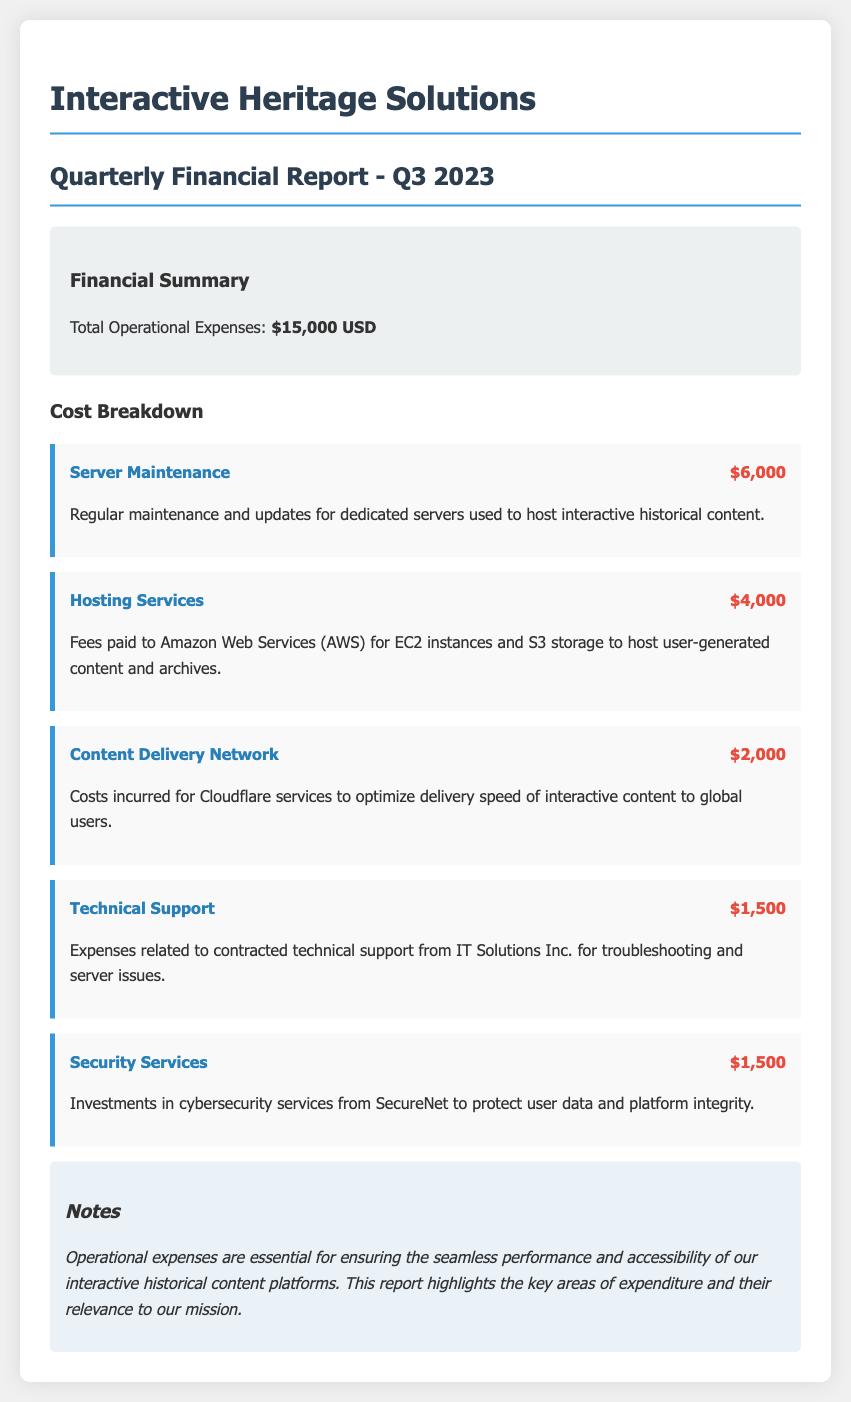What is the total operational expenses? The total operational expenses is stated in the summary section of the document as $15,000 USD.
Answer: $15,000 USD How much was spent on server maintenance? The server maintenance cost is detailed in the cost breakdown section, and it indicates an expenditure of $6,000.
Answer: $6,000 What service incurred a cost of $4,000? The hosting services cost is specified in the breakdown as $4,000, referring to fees paid to Amazon Web Services.
Answer: Hosting Services What was the cost for the content delivery network? The cost breakdown lists the content delivery network expense as $2,000.
Answer: $2,000 What is the combined total for technical support and security services? The total for both technical support ($1,500) and security services ($1,500) is calculated to be $3,000.
Answer: $3,000 What company provides the technical support listed in the report? The technical support is provided by IT Solutions Inc., as mentioned in the document.
Answer: IT Solutions Inc What is the purpose of the operational expenses according to the notes? The notes section states that operational expenses are essential for ensuring seamless performance and accessibility of the platforms.
Answer: Ensuring seamless performance and accessibility How much was spent on cybersecurity services? The report details that $1,500 was invested in cybersecurity services from SecureNet.
Answer: $1,500 What type of document is this? This document is a quarterly financial report specifically for Q3 2023.
Answer: Quarterly financial report 